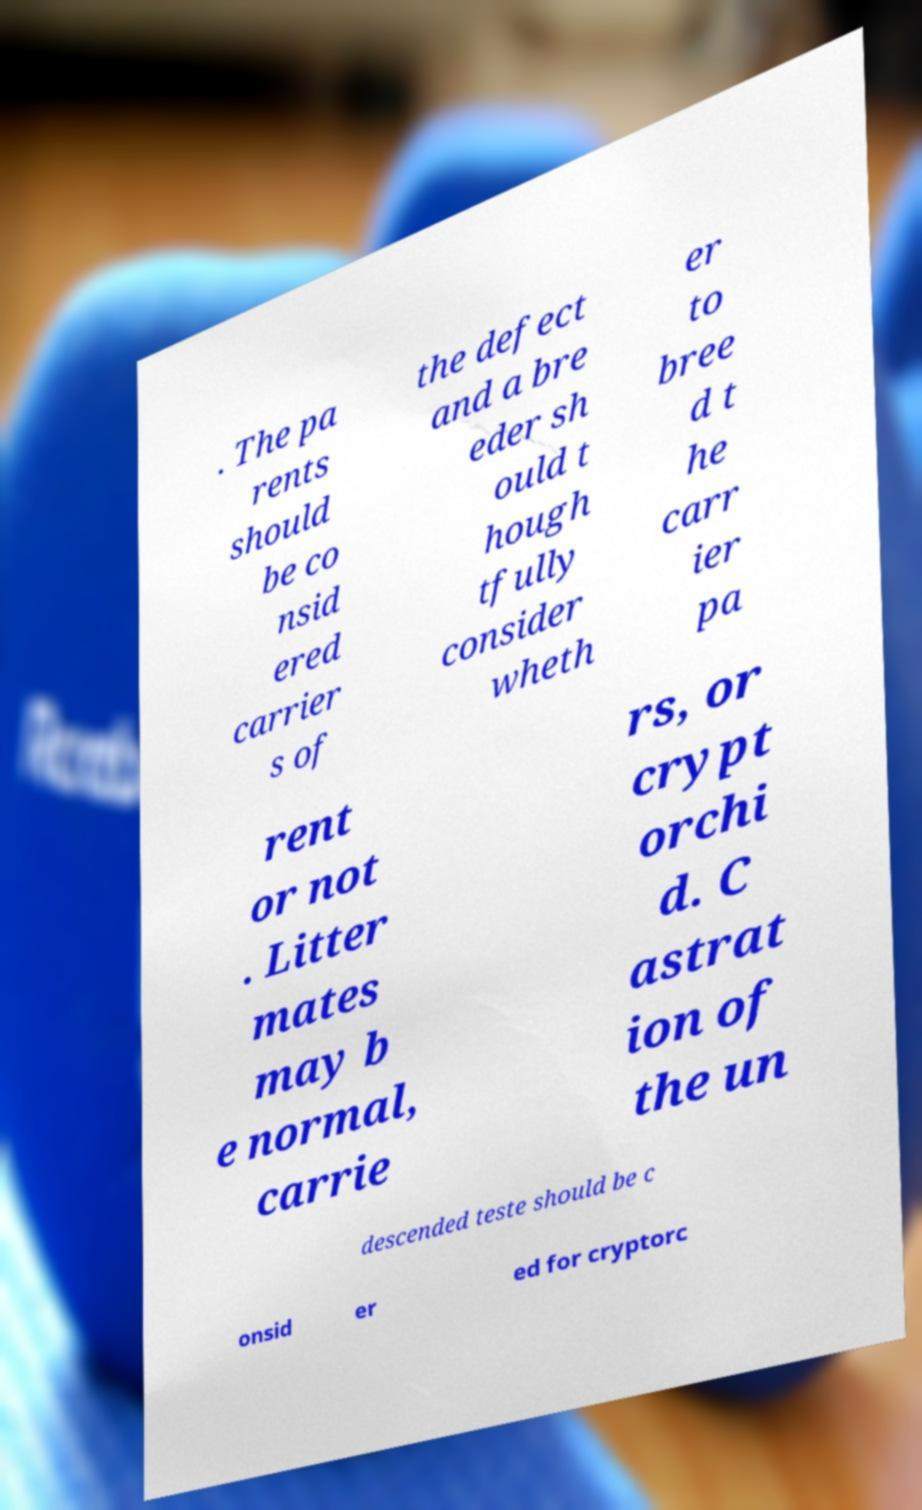For documentation purposes, I need the text within this image transcribed. Could you provide that? . The pa rents should be co nsid ered carrier s of the defect and a bre eder sh ould t hough tfully consider wheth er to bree d t he carr ier pa rent or not . Litter mates may b e normal, carrie rs, or crypt orchi d. C astrat ion of the un descended teste should be c onsid er ed for cryptorc 